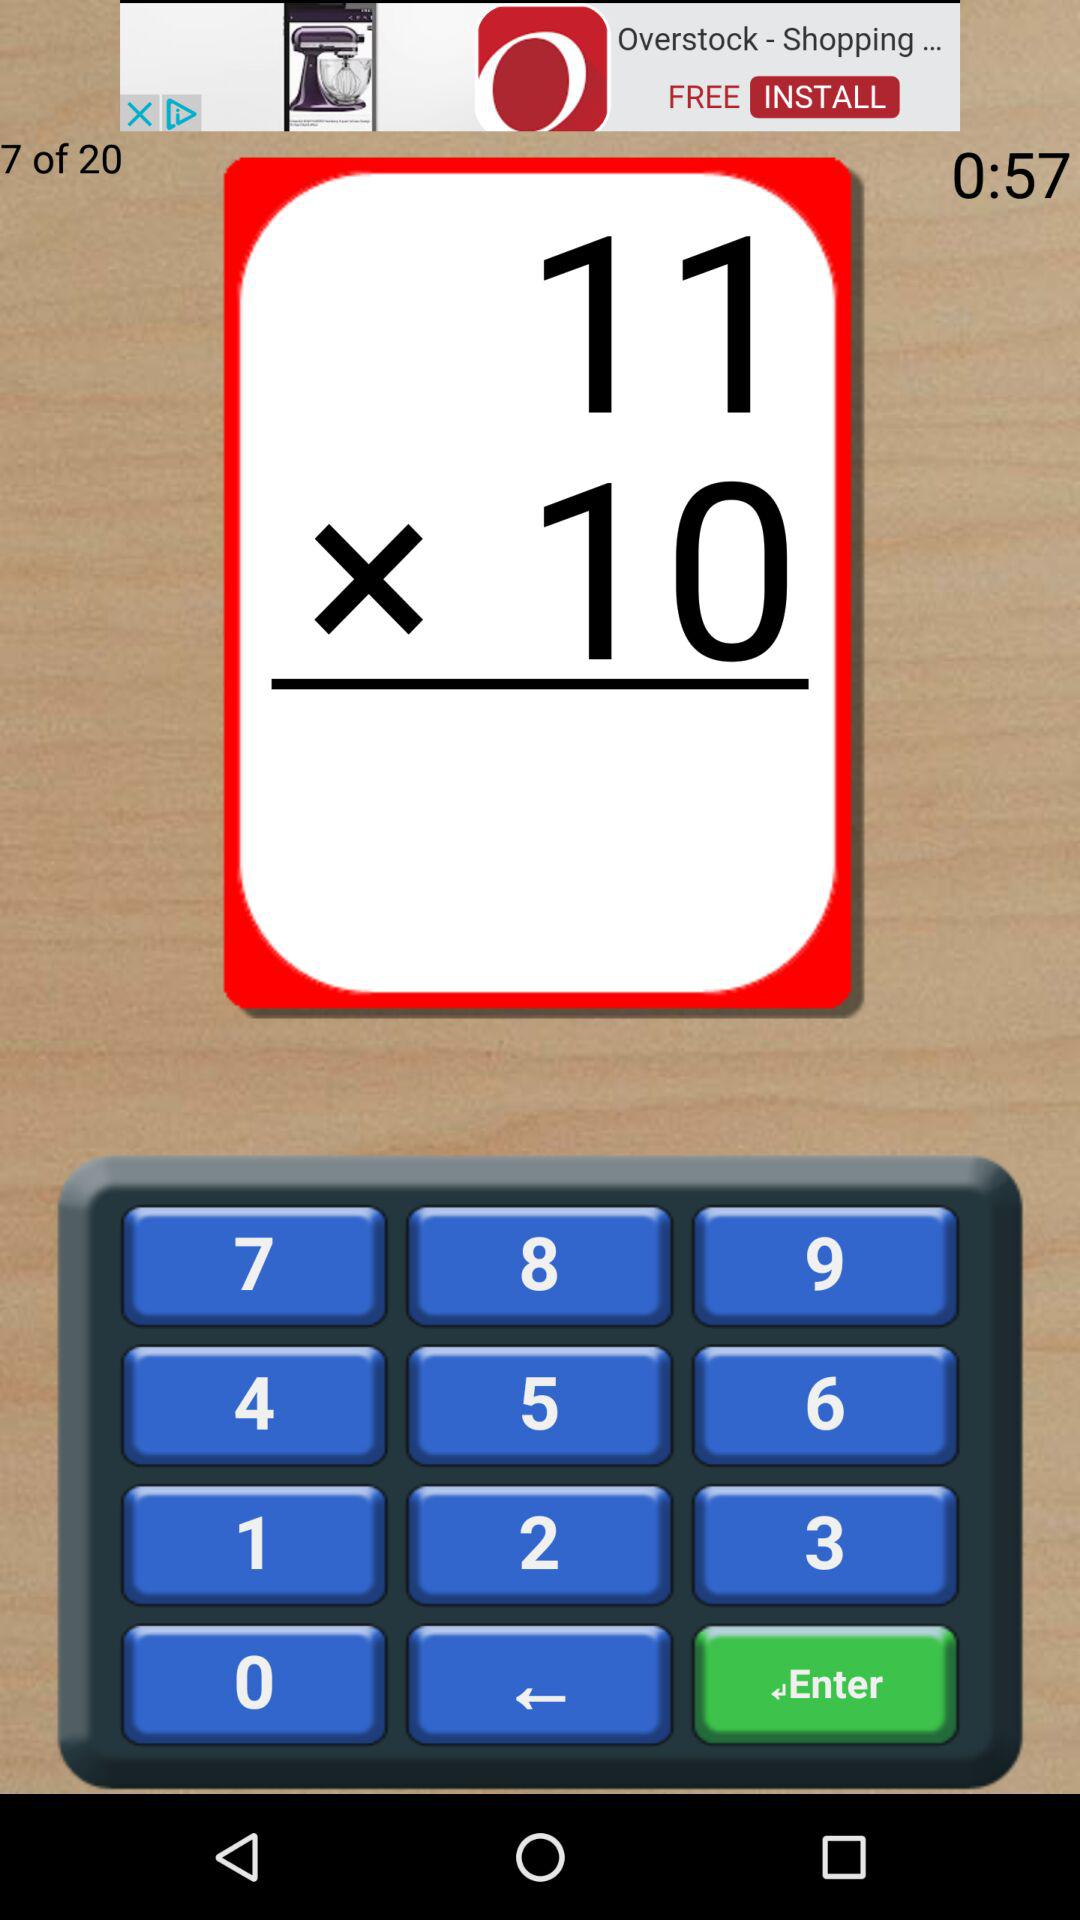Which question number are we currently on? You are currently on question number 7. 